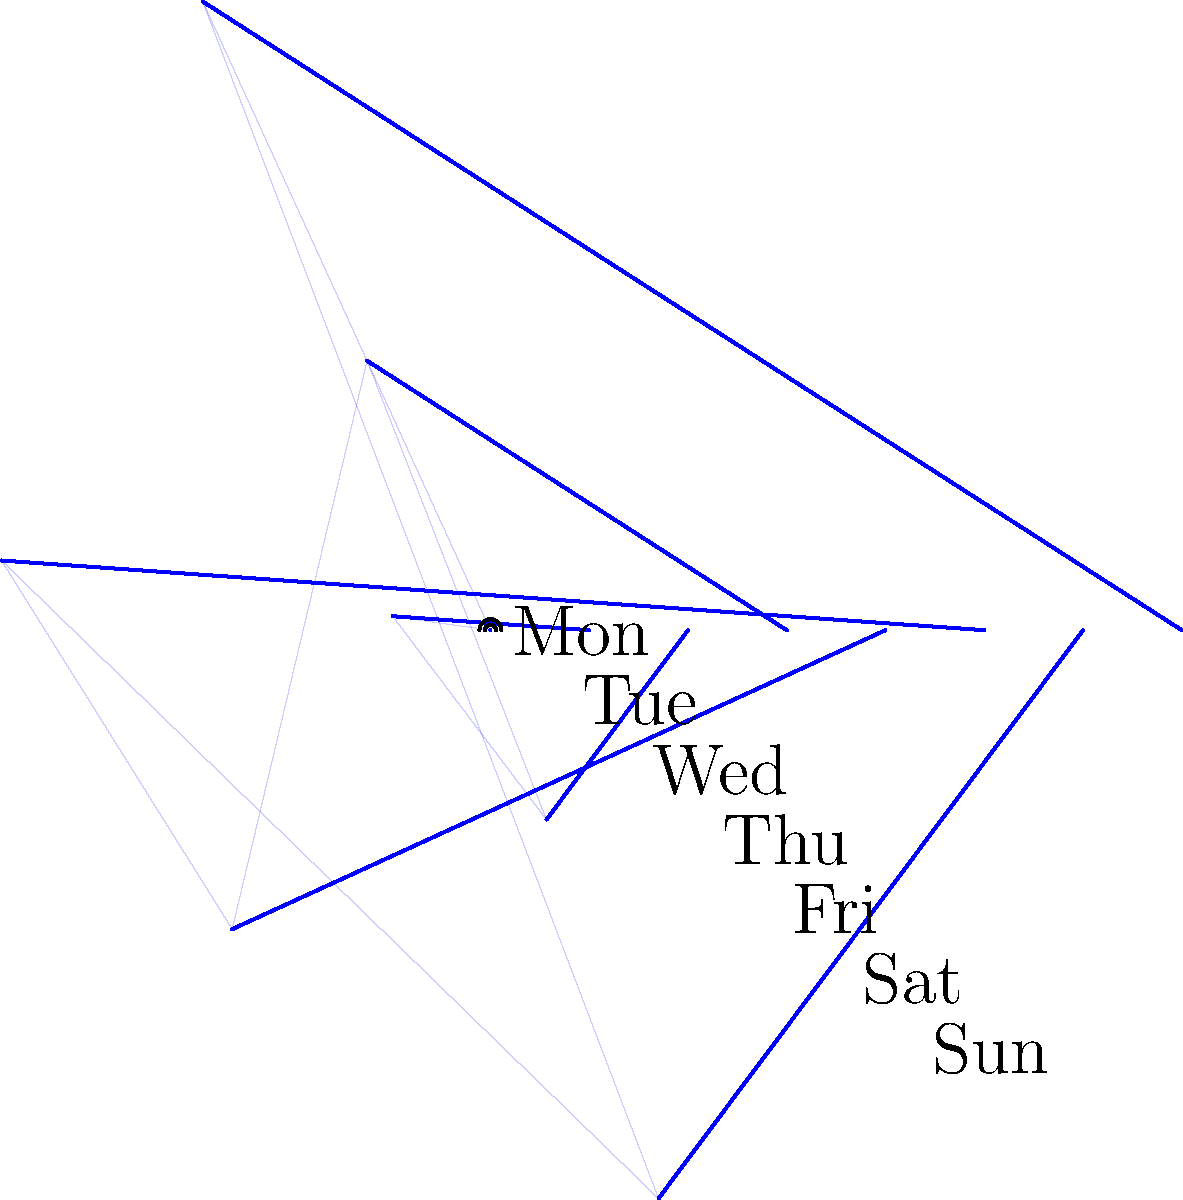As a home health aide, you've been tracking your team's collaboration intensity throughout the week. The polar area chart above represents this data, with the area of each sector indicating the collaboration level for each day. Which two days show the highest levels of team collaboration? To determine the days with the highest levels of team collaboration, we need to compare the areas of the sectors in the polar area chart. The area of each sector is proportional to the square of its radius. Let's analyze the chart step-by-step:

1. Identify the radii for each day:
   Monday (0°): 4
   Tuesday (45°): 3
   Wednesday (90°): 5
   Thursday (135°): 2
   Friday (180°): 4
   Saturday (225°): 3
   Sunday (270°): 5

2. Square the radii to compare the areas:
   Monday: $4^2 = 16$
   Tuesday: $3^2 = 9$
   Wednesday: $5^2 = 25$
   Thursday: $2^2 = 4$
   Friday: $4^2 = 16$
   Saturday: $3^2 = 9$
   Sunday: $5^2 = 25$

3. Identify the two largest values:
   The largest values are 25, corresponding to Wednesday and Sunday.

Therefore, Wednesday and Sunday show the highest levels of team collaboration.
Answer: Wednesday and Sunday 